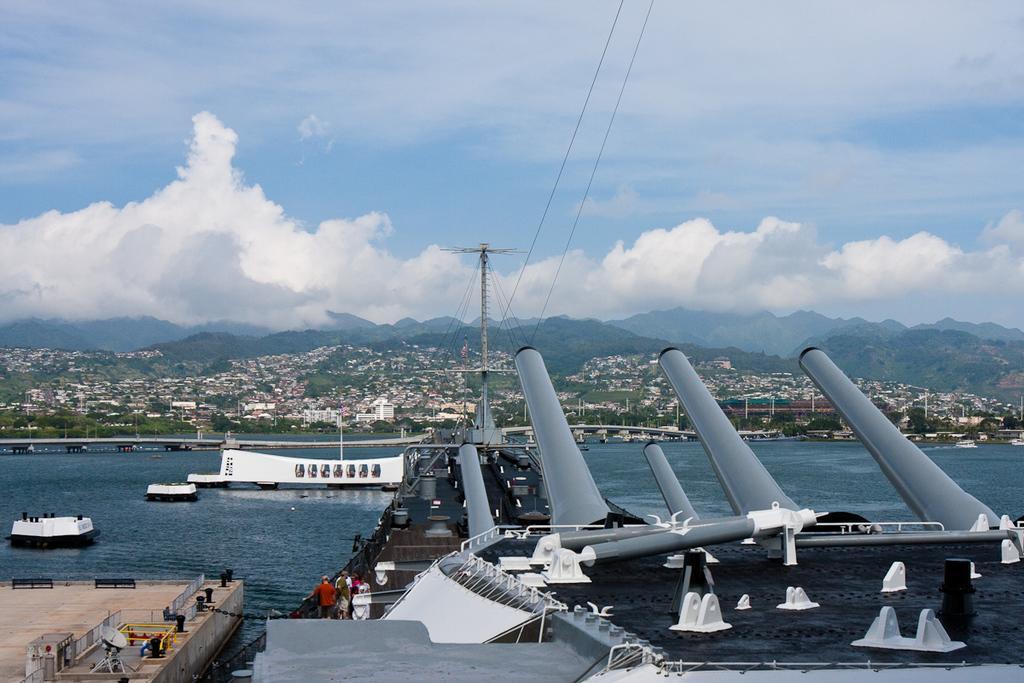How would you summarize this image in a sentence or two? In this image I can see a inner part of the ship. It is in white,ash and blue color. I can see few people inside. Back I can see few boats,bridge,trees,poles,buildings,mountains,wires. I can see a water. The sky is in white and blue color. 